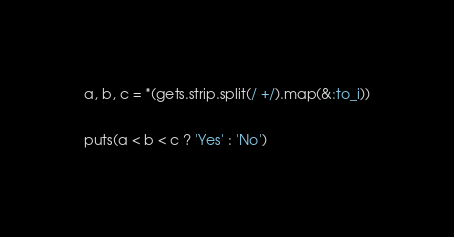<code> <loc_0><loc_0><loc_500><loc_500><_Ruby_>a, b, c = *(gets.strip.split(/ +/).map(&:to_i))
 
puts(a < b < c ? 'Yes' : 'No')</code> 